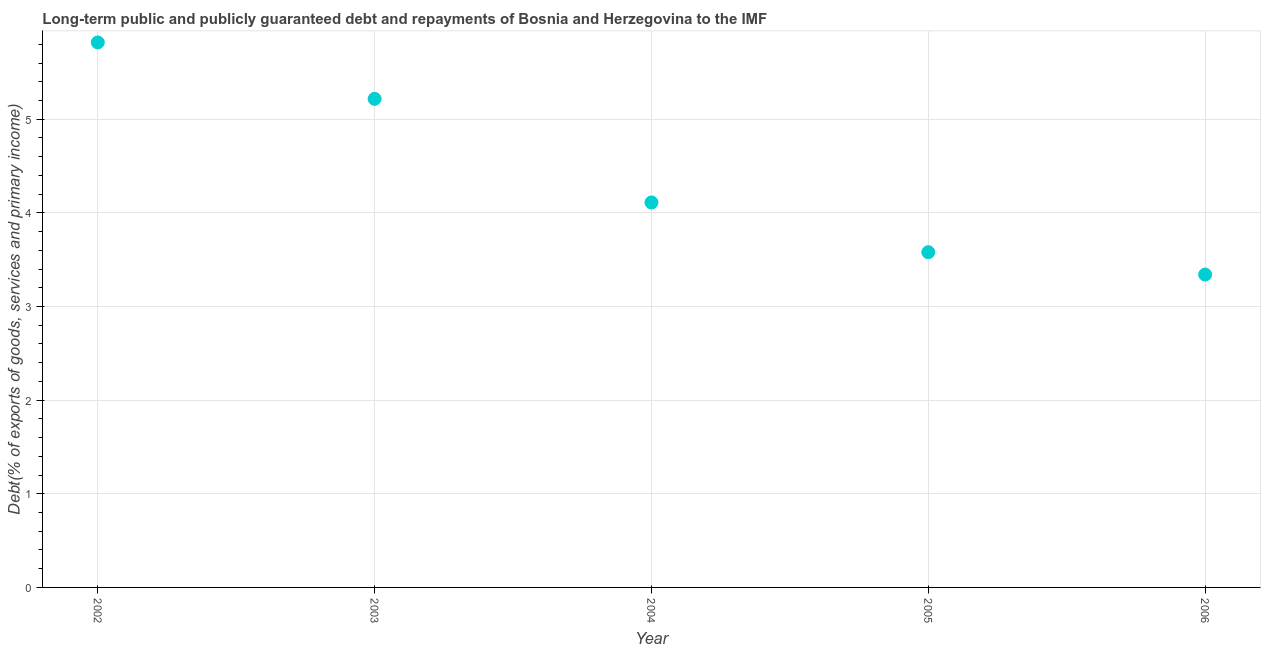What is the debt service in 2003?
Offer a terse response. 5.22. Across all years, what is the maximum debt service?
Your answer should be compact. 5.82. Across all years, what is the minimum debt service?
Make the answer very short. 3.34. In which year was the debt service minimum?
Give a very brief answer. 2006. What is the sum of the debt service?
Give a very brief answer. 22.07. What is the difference between the debt service in 2003 and 2005?
Keep it short and to the point. 1.64. What is the average debt service per year?
Provide a succinct answer. 4.41. What is the median debt service?
Offer a terse response. 4.11. In how many years, is the debt service greater than 2.6 %?
Provide a short and direct response. 5. What is the ratio of the debt service in 2003 to that in 2004?
Your answer should be compact. 1.27. Is the difference between the debt service in 2003 and 2004 greater than the difference between any two years?
Offer a very short reply. No. What is the difference between the highest and the second highest debt service?
Provide a succinct answer. 0.6. Is the sum of the debt service in 2003 and 2004 greater than the maximum debt service across all years?
Make the answer very short. Yes. What is the difference between the highest and the lowest debt service?
Your response must be concise. 2.48. How many years are there in the graph?
Your response must be concise. 5. What is the difference between two consecutive major ticks on the Y-axis?
Your response must be concise. 1. Are the values on the major ticks of Y-axis written in scientific E-notation?
Offer a terse response. No. Does the graph contain grids?
Offer a very short reply. Yes. What is the title of the graph?
Give a very brief answer. Long-term public and publicly guaranteed debt and repayments of Bosnia and Herzegovina to the IMF. What is the label or title of the Y-axis?
Make the answer very short. Debt(% of exports of goods, services and primary income). What is the Debt(% of exports of goods, services and primary income) in 2002?
Ensure brevity in your answer.  5.82. What is the Debt(% of exports of goods, services and primary income) in 2003?
Provide a succinct answer. 5.22. What is the Debt(% of exports of goods, services and primary income) in 2004?
Give a very brief answer. 4.11. What is the Debt(% of exports of goods, services and primary income) in 2005?
Offer a very short reply. 3.58. What is the Debt(% of exports of goods, services and primary income) in 2006?
Your answer should be very brief. 3.34. What is the difference between the Debt(% of exports of goods, services and primary income) in 2002 and 2003?
Provide a short and direct response. 0.6. What is the difference between the Debt(% of exports of goods, services and primary income) in 2002 and 2004?
Your response must be concise. 1.71. What is the difference between the Debt(% of exports of goods, services and primary income) in 2002 and 2005?
Offer a terse response. 2.24. What is the difference between the Debt(% of exports of goods, services and primary income) in 2002 and 2006?
Make the answer very short. 2.48. What is the difference between the Debt(% of exports of goods, services and primary income) in 2003 and 2004?
Your response must be concise. 1.11. What is the difference between the Debt(% of exports of goods, services and primary income) in 2003 and 2005?
Provide a short and direct response. 1.64. What is the difference between the Debt(% of exports of goods, services and primary income) in 2003 and 2006?
Provide a short and direct response. 1.88. What is the difference between the Debt(% of exports of goods, services and primary income) in 2004 and 2005?
Give a very brief answer. 0.53. What is the difference between the Debt(% of exports of goods, services and primary income) in 2004 and 2006?
Offer a terse response. 0.77. What is the difference between the Debt(% of exports of goods, services and primary income) in 2005 and 2006?
Your answer should be very brief. 0.24. What is the ratio of the Debt(% of exports of goods, services and primary income) in 2002 to that in 2003?
Make the answer very short. 1.11. What is the ratio of the Debt(% of exports of goods, services and primary income) in 2002 to that in 2004?
Your response must be concise. 1.42. What is the ratio of the Debt(% of exports of goods, services and primary income) in 2002 to that in 2005?
Offer a very short reply. 1.63. What is the ratio of the Debt(% of exports of goods, services and primary income) in 2002 to that in 2006?
Offer a terse response. 1.74. What is the ratio of the Debt(% of exports of goods, services and primary income) in 2003 to that in 2004?
Give a very brief answer. 1.27. What is the ratio of the Debt(% of exports of goods, services and primary income) in 2003 to that in 2005?
Give a very brief answer. 1.46. What is the ratio of the Debt(% of exports of goods, services and primary income) in 2003 to that in 2006?
Make the answer very short. 1.56. What is the ratio of the Debt(% of exports of goods, services and primary income) in 2004 to that in 2005?
Give a very brief answer. 1.15. What is the ratio of the Debt(% of exports of goods, services and primary income) in 2004 to that in 2006?
Ensure brevity in your answer.  1.23. What is the ratio of the Debt(% of exports of goods, services and primary income) in 2005 to that in 2006?
Offer a very short reply. 1.07. 